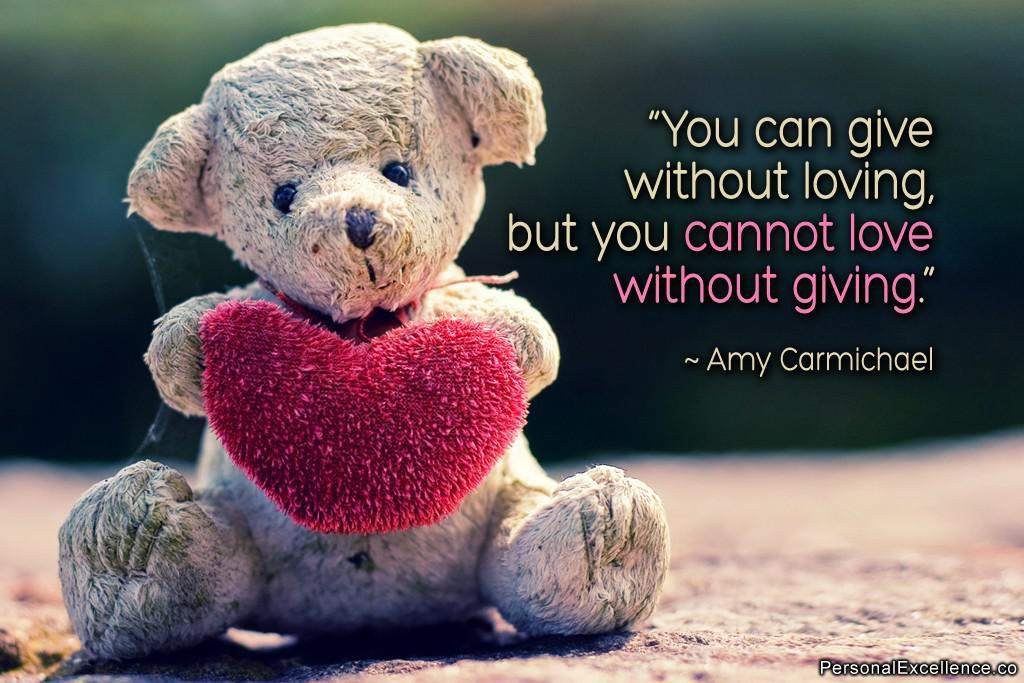What type of object is in the image? There is a teddy bear in the image. What colors can be seen on the teddy bear? The teddy bear has brown and red colors. Is there any text or writing present in the image? Yes, there is text or writing on the image. How would you describe the background of the image? The background of the image is blurred. What is the rate of the tooth's growth in the image? There is no tooth present in the image, so it is not possible to determine the rate of its growth. 